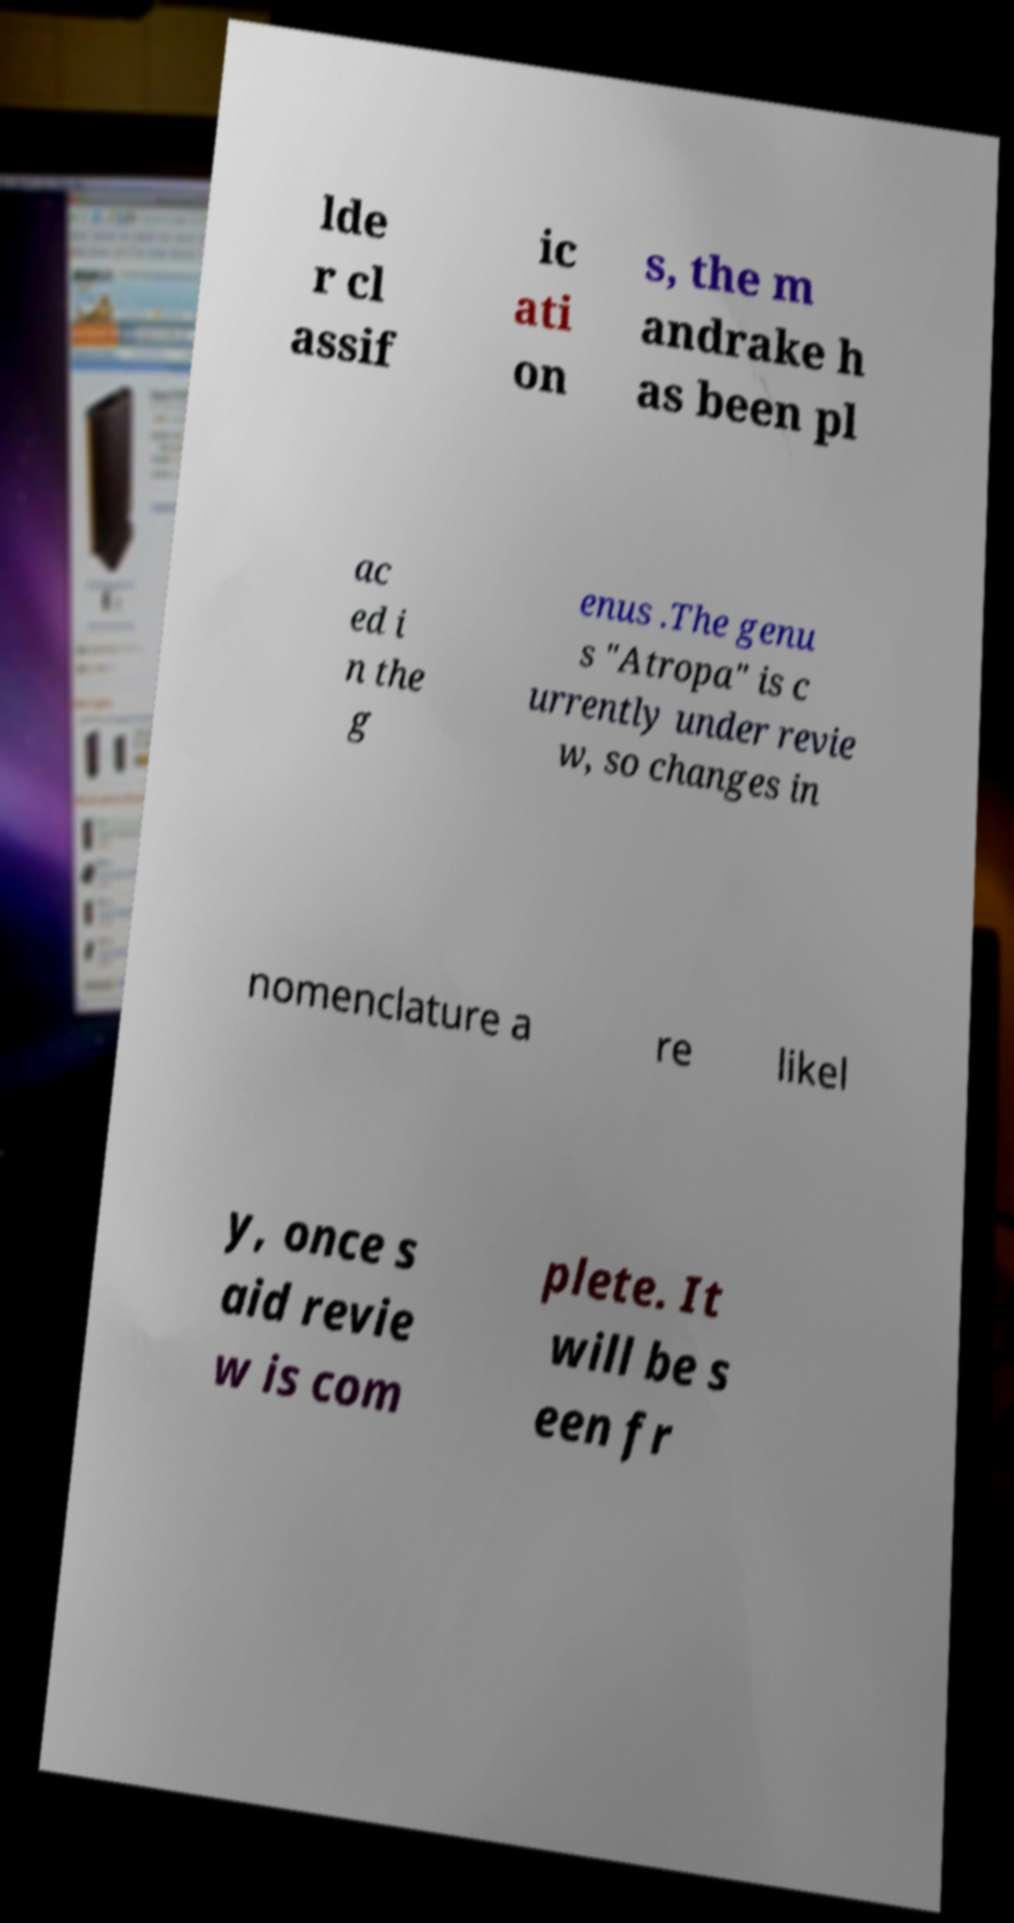Can you accurately transcribe the text from the provided image for me? lde r cl assif ic ati on s, the m andrake h as been pl ac ed i n the g enus .The genu s "Atropa" is c urrently under revie w, so changes in nomenclature a re likel y, once s aid revie w is com plete. It will be s een fr 